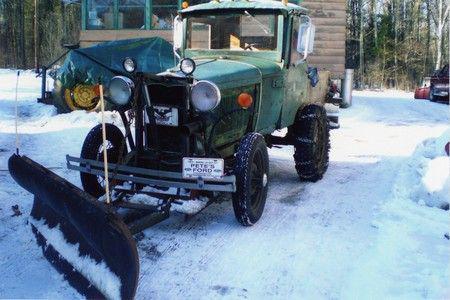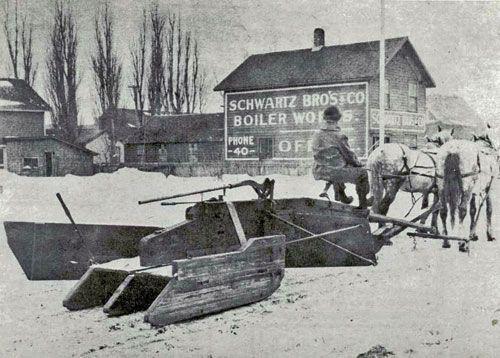The first image is the image on the left, the second image is the image on the right. For the images shown, is this caption "Both images in the pair are in black and white." true? Answer yes or no. No. 